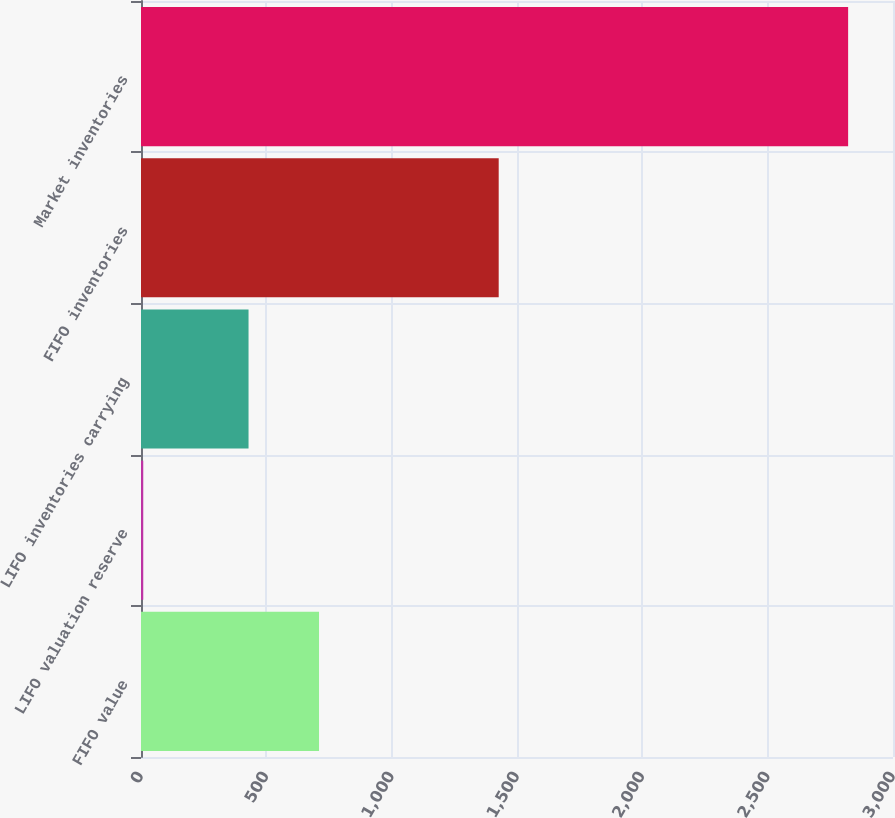<chart> <loc_0><loc_0><loc_500><loc_500><bar_chart><fcel>FIFO value<fcel>LIFO valuation reserve<fcel>LIFO inventories carrying<fcel>FIFO inventories<fcel>Market inventories<nl><fcel>710.2<fcel>9<fcel>429<fcel>1427<fcel>2821<nl></chart> 